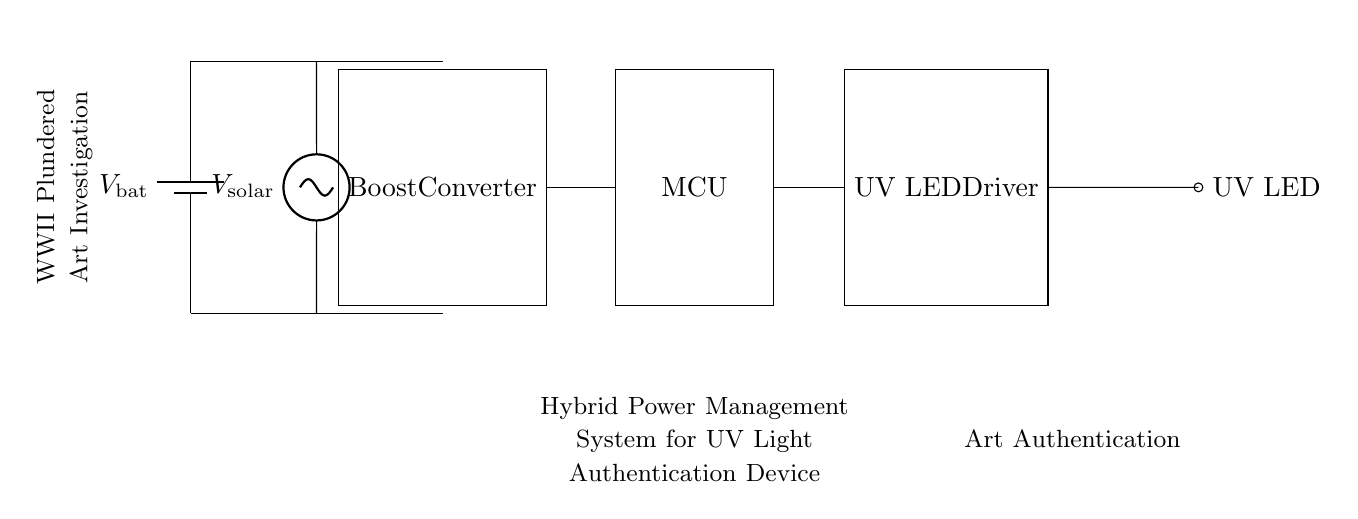What is the main power source in this hybrid circuit? The main power sources are the battery and the solar panel, which provide the necessary voltage to the circuit. Both are located at the left side of the diagram.
Answer: battery and solar panel What component is used to increase voltage in the circuit? The boost converter is the component responsible for increasing the voltage to the required level for the microcontroller and the UV LED driver. It is clearly labeled within the circuit diagram.
Answer: Boost Converter What does MCU stand for in this diagram? MCU stands for Microcontroller Unit, which is shown in the circuit as a distinct block connected to other components.
Answer: Microcontroller Unit How many components are required for UV light operation? There are three key components required for the UV light operation: the UV LED driver, the UV LED, and the microcontroller which controls the driver.
Answer: three What type of device is the circuit designed to power? The circuit is designed to power a portable UV light device, specifically for the purpose of art authentication. This is indicated by the labels present in the diagram.
Answer: portable UV light device What distinguishes this circuit as a hybrid power management system? This circuit is classified as a hybrid power management system because it utilizes both a battery and a solar panel to provide power, ensuring continuous functionality in varying conditions.
Answer: both battery and solar panel 